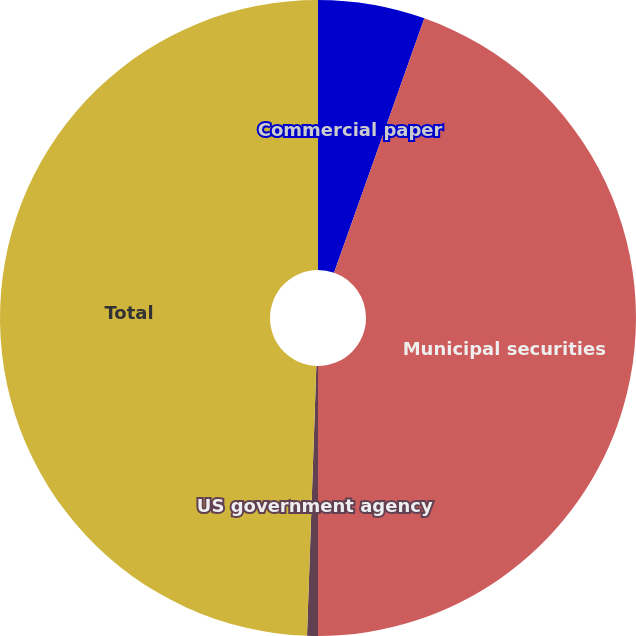Convert chart to OTSL. <chart><loc_0><loc_0><loc_500><loc_500><pie_chart><fcel>Commercial paper<fcel>Municipal securities<fcel>US government agency<fcel>Total<nl><fcel>5.43%<fcel>44.57%<fcel>0.55%<fcel>49.45%<nl></chart> 